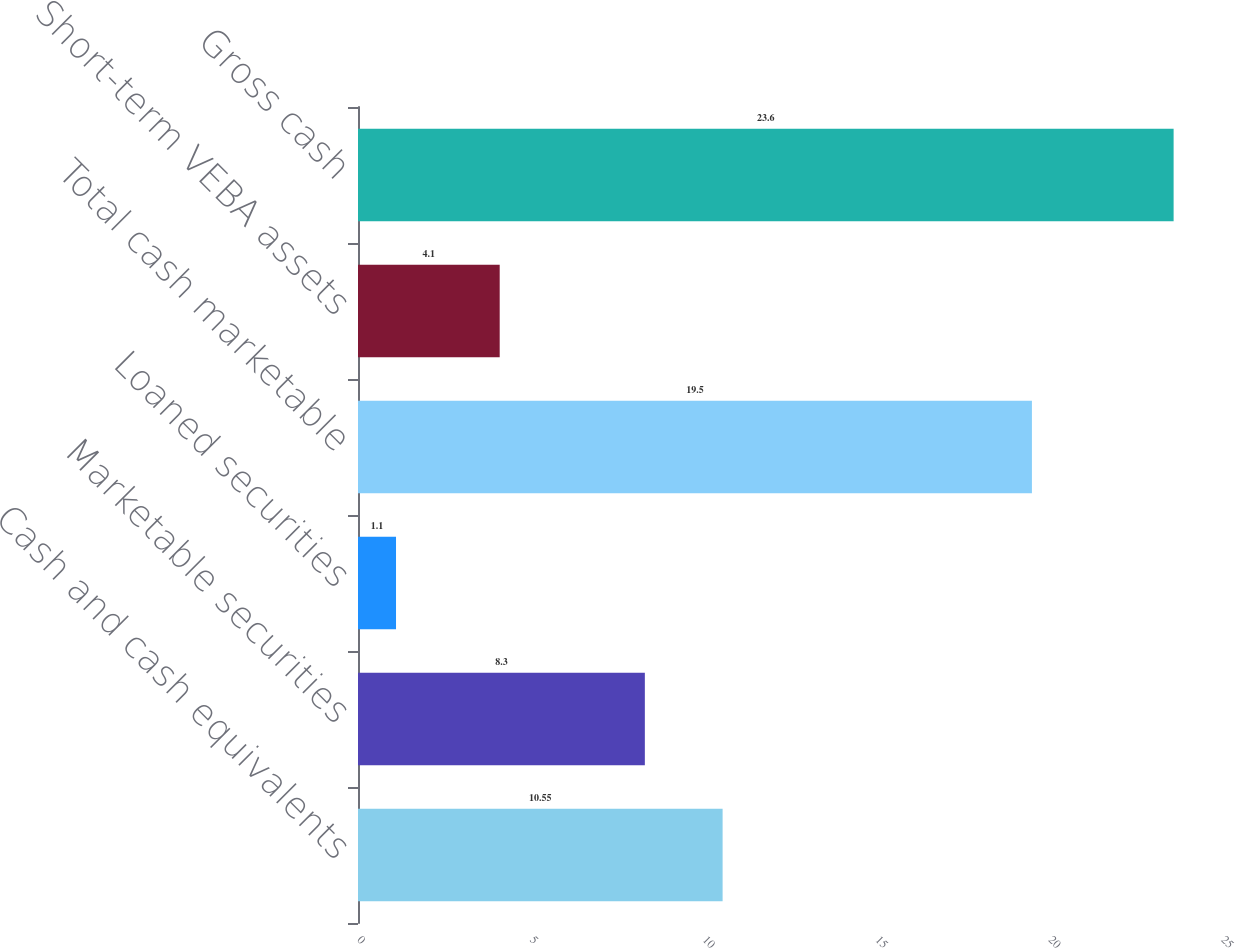Convert chart. <chart><loc_0><loc_0><loc_500><loc_500><bar_chart><fcel>Cash and cash equivalents<fcel>Marketable securities<fcel>Loaned securities<fcel>Total cash marketable<fcel>Short-term VEBA assets<fcel>Gross cash<nl><fcel>10.55<fcel>8.3<fcel>1.1<fcel>19.5<fcel>4.1<fcel>23.6<nl></chart> 